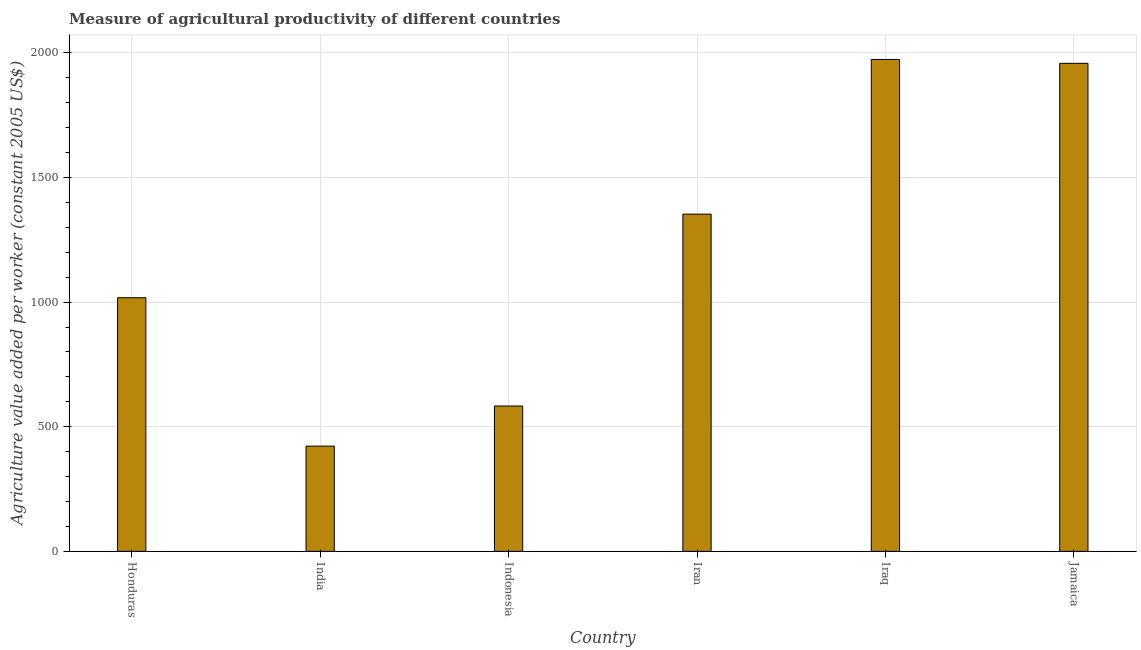What is the title of the graph?
Keep it short and to the point. Measure of agricultural productivity of different countries. What is the label or title of the Y-axis?
Give a very brief answer. Agriculture value added per worker (constant 2005 US$). What is the agriculture value added per worker in India?
Your answer should be compact. 422.14. Across all countries, what is the maximum agriculture value added per worker?
Keep it short and to the point. 1973.38. Across all countries, what is the minimum agriculture value added per worker?
Offer a terse response. 422.14. In which country was the agriculture value added per worker maximum?
Offer a terse response. Iraq. In which country was the agriculture value added per worker minimum?
Give a very brief answer. India. What is the sum of the agriculture value added per worker?
Offer a very short reply. 7306.94. What is the difference between the agriculture value added per worker in India and Indonesia?
Make the answer very short. -160.98. What is the average agriculture value added per worker per country?
Make the answer very short. 1217.82. What is the median agriculture value added per worker?
Provide a succinct answer. 1185.23. In how many countries, is the agriculture value added per worker greater than 1100 US$?
Provide a short and direct response. 3. What is the ratio of the agriculture value added per worker in Indonesia to that in Jamaica?
Offer a terse response. 0.3. What is the difference between the highest and the second highest agriculture value added per worker?
Offer a terse response. 15.52. Is the sum of the agriculture value added per worker in India and Iran greater than the maximum agriculture value added per worker across all countries?
Your answer should be very brief. No. What is the difference between the highest and the lowest agriculture value added per worker?
Ensure brevity in your answer.  1551.24. How many bars are there?
Your response must be concise. 6. Are the values on the major ticks of Y-axis written in scientific E-notation?
Your response must be concise. No. What is the Agriculture value added per worker (constant 2005 US$) in Honduras?
Provide a short and direct response. 1017.54. What is the Agriculture value added per worker (constant 2005 US$) in India?
Your answer should be compact. 422.14. What is the Agriculture value added per worker (constant 2005 US$) in Indonesia?
Provide a short and direct response. 583.11. What is the Agriculture value added per worker (constant 2005 US$) in Iran?
Your answer should be compact. 1352.92. What is the Agriculture value added per worker (constant 2005 US$) of Iraq?
Keep it short and to the point. 1973.38. What is the Agriculture value added per worker (constant 2005 US$) in Jamaica?
Offer a terse response. 1957.86. What is the difference between the Agriculture value added per worker (constant 2005 US$) in Honduras and India?
Provide a short and direct response. 595.41. What is the difference between the Agriculture value added per worker (constant 2005 US$) in Honduras and Indonesia?
Your answer should be very brief. 434.43. What is the difference between the Agriculture value added per worker (constant 2005 US$) in Honduras and Iran?
Ensure brevity in your answer.  -335.38. What is the difference between the Agriculture value added per worker (constant 2005 US$) in Honduras and Iraq?
Offer a terse response. -955.83. What is the difference between the Agriculture value added per worker (constant 2005 US$) in Honduras and Jamaica?
Keep it short and to the point. -940.32. What is the difference between the Agriculture value added per worker (constant 2005 US$) in India and Indonesia?
Provide a short and direct response. -160.98. What is the difference between the Agriculture value added per worker (constant 2005 US$) in India and Iran?
Offer a terse response. -930.78. What is the difference between the Agriculture value added per worker (constant 2005 US$) in India and Iraq?
Provide a short and direct response. -1551.24. What is the difference between the Agriculture value added per worker (constant 2005 US$) in India and Jamaica?
Ensure brevity in your answer.  -1535.72. What is the difference between the Agriculture value added per worker (constant 2005 US$) in Indonesia and Iran?
Offer a terse response. -769.81. What is the difference between the Agriculture value added per worker (constant 2005 US$) in Indonesia and Iraq?
Make the answer very short. -1390.26. What is the difference between the Agriculture value added per worker (constant 2005 US$) in Indonesia and Jamaica?
Offer a terse response. -1374.74. What is the difference between the Agriculture value added per worker (constant 2005 US$) in Iran and Iraq?
Provide a succinct answer. -620.46. What is the difference between the Agriculture value added per worker (constant 2005 US$) in Iran and Jamaica?
Your answer should be compact. -604.94. What is the difference between the Agriculture value added per worker (constant 2005 US$) in Iraq and Jamaica?
Offer a terse response. 15.52. What is the ratio of the Agriculture value added per worker (constant 2005 US$) in Honduras to that in India?
Your answer should be very brief. 2.41. What is the ratio of the Agriculture value added per worker (constant 2005 US$) in Honduras to that in Indonesia?
Your answer should be very brief. 1.75. What is the ratio of the Agriculture value added per worker (constant 2005 US$) in Honduras to that in Iran?
Your answer should be compact. 0.75. What is the ratio of the Agriculture value added per worker (constant 2005 US$) in Honduras to that in Iraq?
Offer a terse response. 0.52. What is the ratio of the Agriculture value added per worker (constant 2005 US$) in Honduras to that in Jamaica?
Your response must be concise. 0.52. What is the ratio of the Agriculture value added per worker (constant 2005 US$) in India to that in Indonesia?
Ensure brevity in your answer.  0.72. What is the ratio of the Agriculture value added per worker (constant 2005 US$) in India to that in Iran?
Keep it short and to the point. 0.31. What is the ratio of the Agriculture value added per worker (constant 2005 US$) in India to that in Iraq?
Offer a terse response. 0.21. What is the ratio of the Agriculture value added per worker (constant 2005 US$) in India to that in Jamaica?
Keep it short and to the point. 0.22. What is the ratio of the Agriculture value added per worker (constant 2005 US$) in Indonesia to that in Iran?
Provide a short and direct response. 0.43. What is the ratio of the Agriculture value added per worker (constant 2005 US$) in Indonesia to that in Iraq?
Offer a very short reply. 0.29. What is the ratio of the Agriculture value added per worker (constant 2005 US$) in Indonesia to that in Jamaica?
Keep it short and to the point. 0.3. What is the ratio of the Agriculture value added per worker (constant 2005 US$) in Iran to that in Iraq?
Provide a succinct answer. 0.69. What is the ratio of the Agriculture value added per worker (constant 2005 US$) in Iran to that in Jamaica?
Your response must be concise. 0.69. 